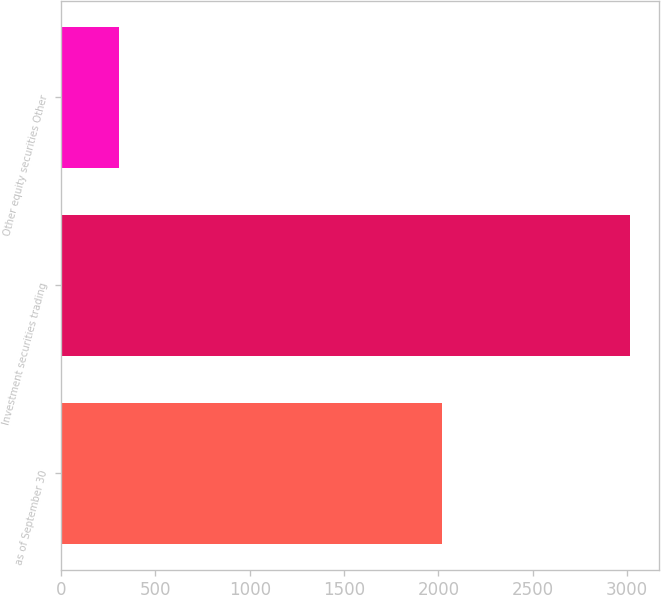Convert chart. <chart><loc_0><loc_0><loc_500><loc_500><bar_chart><fcel>as of September 30<fcel>Investment securities trading<fcel>Other equity securities Other<nl><fcel>2017<fcel>3017.2<fcel>306.9<nl></chart> 